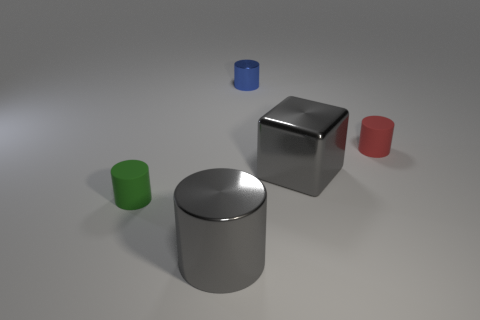Is the color of the large cylinder the same as the cube?
Make the answer very short. Yes. What shape is the blue object?
Provide a succinct answer. Cylinder. Are there any large cubes of the same color as the large cylinder?
Offer a very short reply. Yes. Is the number of metal objects left of the gray metallic block greater than the number of big yellow matte cubes?
Give a very brief answer. Yes. There is a small red thing; does it have the same shape as the small thing that is left of the blue thing?
Your response must be concise. Yes. Is there a big gray rubber sphere?
Your response must be concise. No. What number of big objects are either blue cylinders or red cylinders?
Your answer should be compact. 0. Is the number of cylinders behind the green thing greater than the number of large metallic blocks that are to the right of the tiny red cylinder?
Your answer should be very brief. Yes. Is the material of the tiny green cylinder the same as the gray object on the left side of the big gray cube?
Offer a very short reply. No. The large cylinder has what color?
Give a very brief answer. Gray. 